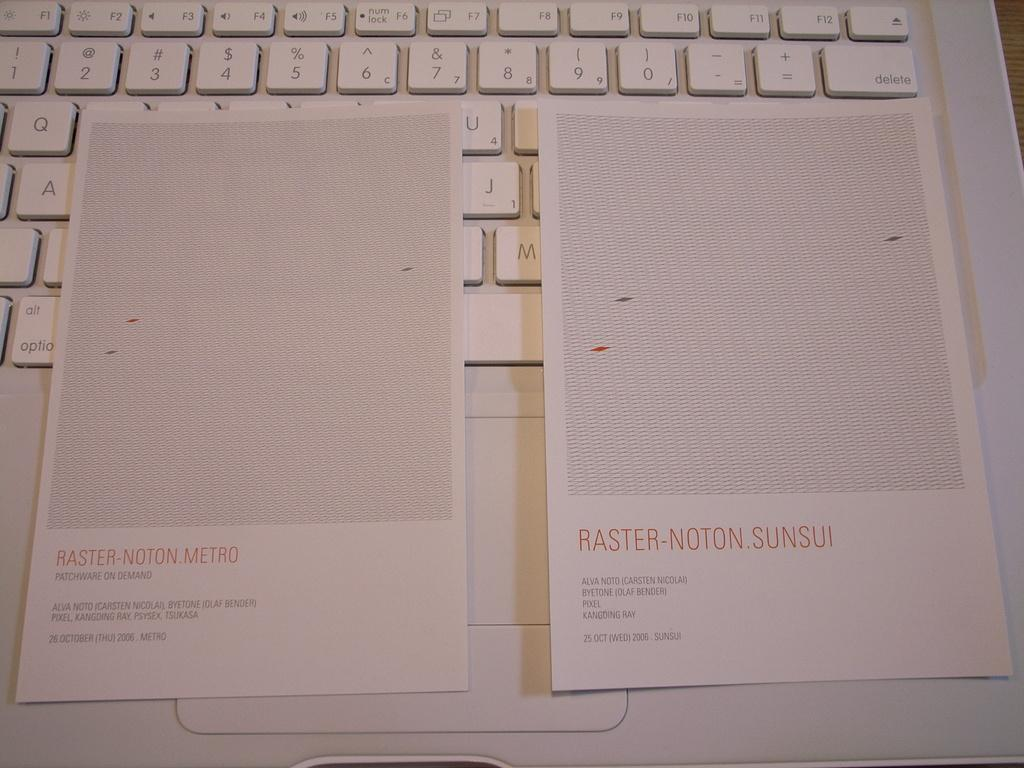<image>
Present a compact description of the photo's key features. Two pages labeled Raster Notion Metro and Raster Notion Sunsui are resting on a white computer keyboard. 